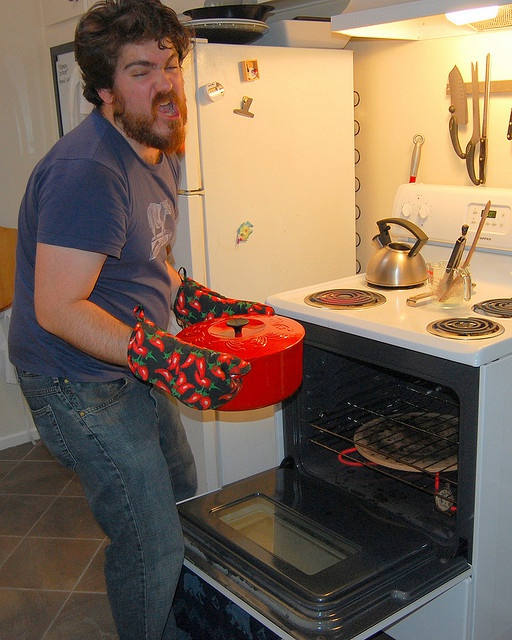Describe the objects in this image and their specific colors. I can see oven in gray, black, darkgray, and tan tones, people in gray, black, and brown tones, refrigerator in gray and tan tones, cup in gray, tan, and red tones, and knife in gray, tan, olive, and maroon tones in this image. 